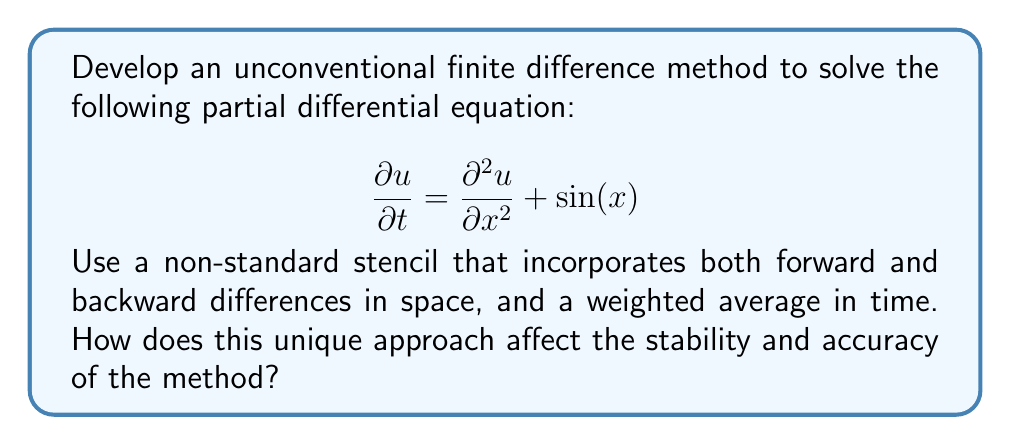What is the answer to this math problem? Let's approach this problem step-by-step:

1) First, we'll define our unique stencil. Let's use a combination of forward and backward differences for the spatial derivative, and a weighted average for the time derivative:

   $$\frac{u_i^{n+1} - u_i^n}{\Delta t} = \alpha \left(\frac{u_{i+1}^n - u_i^n}{\Delta x^2}\right) + (1-\alpha) \left(\frac{u_i^n - u_{i-1}^n}{\Delta x^2}\right) + \sin(x_i)$$

   where $\alpha$ is a weighting parameter (0 ≤ $\alpha$ ≤ 1).

2) Rearranging the equation:

   $$u_i^{n+1} = u_i^n + \frac{\Delta t}{\Delta x^2} [\alpha u_{i+1}^n + (1-2\alpha) u_i^n + (\alpha-1) u_{i-1}^n] + \Delta t \sin(x_i)$$

3) To analyze stability, we can use von Neumann stability analysis. Let $u_i^n = \xi^n e^{ikx_i}$, where $k$ is the wavenumber and $\xi$ is the amplification factor.

4) Substituting this into our scheme:

   $$\xi = 1 + \frac{\Delta t}{\Delta x^2} [\alpha e^{ik\Delta x} + (1-2\alpha) + (\alpha-1) e^{-ik\Delta x}] + \Delta t \sin(x_i)$$

5) For stability, we require $|\xi| \leq 1$. This condition will depend on the choice of $\alpha$.

6) For accuracy, we can perform a Taylor series expansion. The truncation error will be $O(\Delta t, \Delta x^2)$ if $\alpha = 0.5$, which is second-order accurate in space and first-order accurate in time.

7) This unique approach affects stability and accuracy in the following ways:
   - The stability condition depends on the choice of $\alpha$, offering flexibility in balancing stability and accuracy.
   - The method can be made second-order accurate in space by choosing $\alpha = 0.5$, which is an improvement over standard first-order methods.
   - The weighted average in time allows for better control of numerical dissipation.

8) However, this method may be more computationally expensive than standard methods due to the additional calculations required for the weighted averages.
Answer: The unique finite difference method offers flexible stability conditions, potential for second-order spatial accuracy, and better control of numerical dissipation, at the cost of increased computational complexity. 